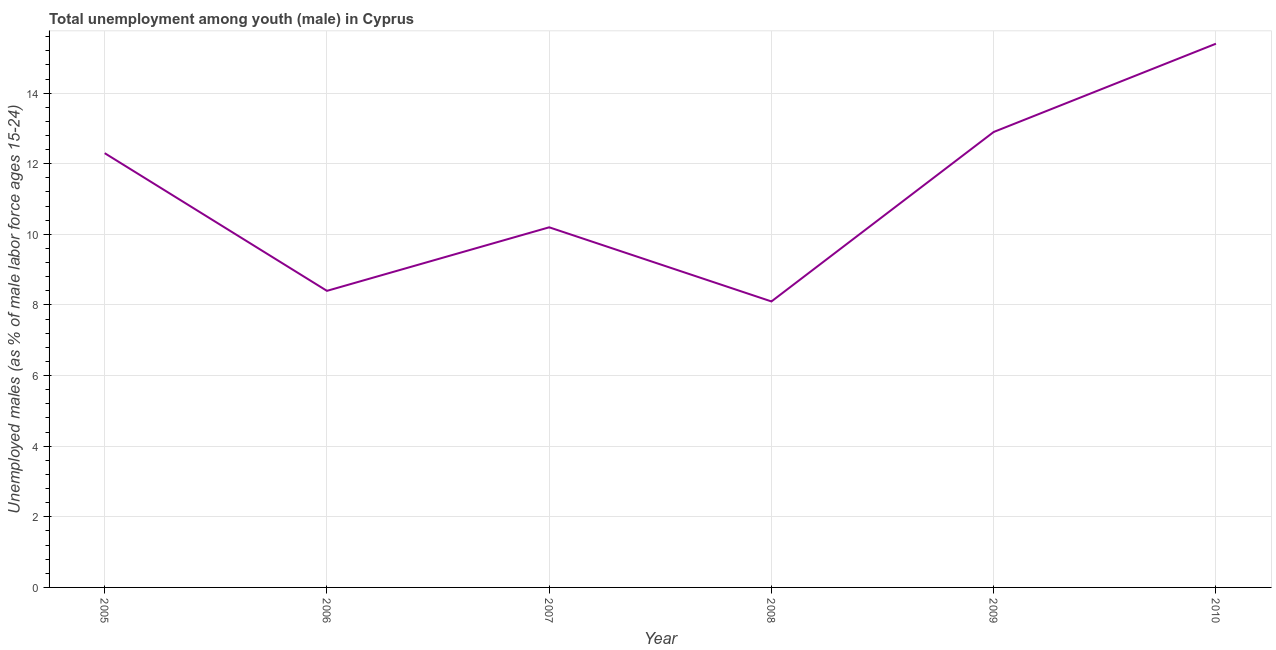What is the unemployed male youth population in 2005?
Offer a very short reply. 12.3. Across all years, what is the maximum unemployed male youth population?
Give a very brief answer. 15.4. Across all years, what is the minimum unemployed male youth population?
Provide a short and direct response. 8.1. In which year was the unemployed male youth population minimum?
Keep it short and to the point. 2008. What is the sum of the unemployed male youth population?
Give a very brief answer. 67.3. What is the difference between the unemployed male youth population in 2007 and 2009?
Offer a very short reply. -2.7. What is the average unemployed male youth population per year?
Ensure brevity in your answer.  11.22. What is the median unemployed male youth population?
Give a very brief answer. 11.25. Do a majority of the years between 2010 and 2009 (inclusive) have unemployed male youth population greater than 4.8 %?
Your answer should be very brief. No. What is the ratio of the unemployed male youth population in 2007 to that in 2008?
Provide a short and direct response. 1.26. Is the difference between the unemployed male youth population in 2006 and 2010 greater than the difference between any two years?
Provide a short and direct response. No. Is the sum of the unemployed male youth population in 2009 and 2010 greater than the maximum unemployed male youth population across all years?
Your answer should be very brief. Yes. What is the difference between the highest and the lowest unemployed male youth population?
Your answer should be compact. 7.3. How many years are there in the graph?
Provide a short and direct response. 6. What is the difference between two consecutive major ticks on the Y-axis?
Provide a succinct answer. 2. Are the values on the major ticks of Y-axis written in scientific E-notation?
Your answer should be very brief. No. Does the graph contain grids?
Offer a terse response. Yes. What is the title of the graph?
Provide a succinct answer. Total unemployment among youth (male) in Cyprus. What is the label or title of the X-axis?
Offer a terse response. Year. What is the label or title of the Y-axis?
Offer a terse response. Unemployed males (as % of male labor force ages 15-24). What is the Unemployed males (as % of male labor force ages 15-24) in 2005?
Provide a short and direct response. 12.3. What is the Unemployed males (as % of male labor force ages 15-24) in 2006?
Your response must be concise. 8.4. What is the Unemployed males (as % of male labor force ages 15-24) of 2007?
Your answer should be compact. 10.2. What is the Unemployed males (as % of male labor force ages 15-24) of 2008?
Your response must be concise. 8.1. What is the Unemployed males (as % of male labor force ages 15-24) in 2009?
Give a very brief answer. 12.9. What is the Unemployed males (as % of male labor force ages 15-24) in 2010?
Ensure brevity in your answer.  15.4. What is the difference between the Unemployed males (as % of male labor force ages 15-24) in 2005 and 2008?
Your answer should be very brief. 4.2. What is the difference between the Unemployed males (as % of male labor force ages 15-24) in 2005 and 2009?
Ensure brevity in your answer.  -0.6. What is the difference between the Unemployed males (as % of male labor force ages 15-24) in 2006 and 2009?
Your response must be concise. -4.5. What is the difference between the Unemployed males (as % of male labor force ages 15-24) in 2006 and 2010?
Your answer should be very brief. -7. What is the difference between the Unemployed males (as % of male labor force ages 15-24) in 2007 and 2009?
Offer a very short reply. -2.7. What is the difference between the Unemployed males (as % of male labor force ages 15-24) in 2007 and 2010?
Your answer should be very brief. -5.2. What is the difference between the Unemployed males (as % of male labor force ages 15-24) in 2008 and 2010?
Provide a succinct answer. -7.3. What is the difference between the Unemployed males (as % of male labor force ages 15-24) in 2009 and 2010?
Offer a very short reply. -2.5. What is the ratio of the Unemployed males (as % of male labor force ages 15-24) in 2005 to that in 2006?
Your answer should be very brief. 1.46. What is the ratio of the Unemployed males (as % of male labor force ages 15-24) in 2005 to that in 2007?
Keep it short and to the point. 1.21. What is the ratio of the Unemployed males (as % of male labor force ages 15-24) in 2005 to that in 2008?
Provide a succinct answer. 1.52. What is the ratio of the Unemployed males (as % of male labor force ages 15-24) in 2005 to that in 2009?
Keep it short and to the point. 0.95. What is the ratio of the Unemployed males (as % of male labor force ages 15-24) in 2005 to that in 2010?
Provide a short and direct response. 0.8. What is the ratio of the Unemployed males (as % of male labor force ages 15-24) in 2006 to that in 2007?
Offer a terse response. 0.82. What is the ratio of the Unemployed males (as % of male labor force ages 15-24) in 2006 to that in 2009?
Your response must be concise. 0.65. What is the ratio of the Unemployed males (as % of male labor force ages 15-24) in 2006 to that in 2010?
Keep it short and to the point. 0.55. What is the ratio of the Unemployed males (as % of male labor force ages 15-24) in 2007 to that in 2008?
Give a very brief answer. 1.26. What is the ratio of the Unemployed males (as % of male labor force ages 15-24) in 2007 to that in 2009?
Your response must be concise. 0.79. What is the ratio of the Unemployed males (as % of male labor force ages 15-24) in 2007 to that in 2010?
Keep it short and to the point. 0.66. What is the ratio of the Unemployed males (as % of male labor force ages 15-24) in 2008 to that in 2009?
Ensure brevity in your answer.  0.63. What is the ratio of the Unemployed males (as % of male labor force ages 15-24) in 2008 to that in 2010?
Keep it short and to the point. 0.53. What is the ratio of the Unemployed males (as % of male labor force ages 15-24) in 2009 to that in 2010?
Offer a very short reply. 0.84. 